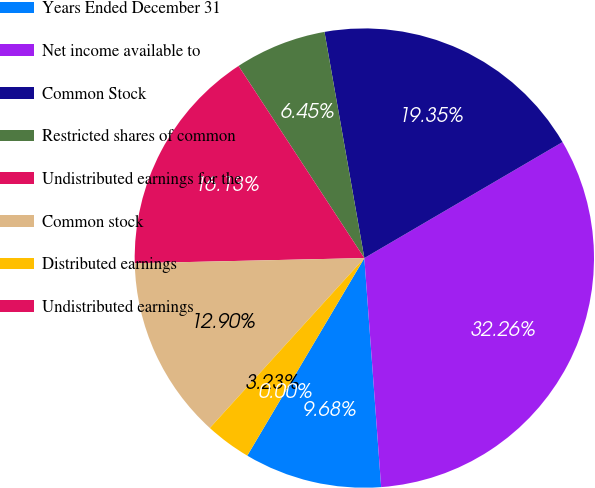Convert chart. <chart><loc_0><loc_0><loc_500><loc_500><pie_chart><fcel>Years Ended December 31<fcel>Net income available to<fcel>Common Stock<fcel>Restricted shares of common<fcel>Undistributed earnings for the<fcel>Common stock<fcel>Distributed earnings<fcel>Undistributed earnings<nl><fcel>9.68%<fcel>32.26%<fcel>19.35%<fcel>6.45%<fcel>16.13%<fcel>12.9%<fcel>3.23%<fcel>0.0%<nl></chart> 